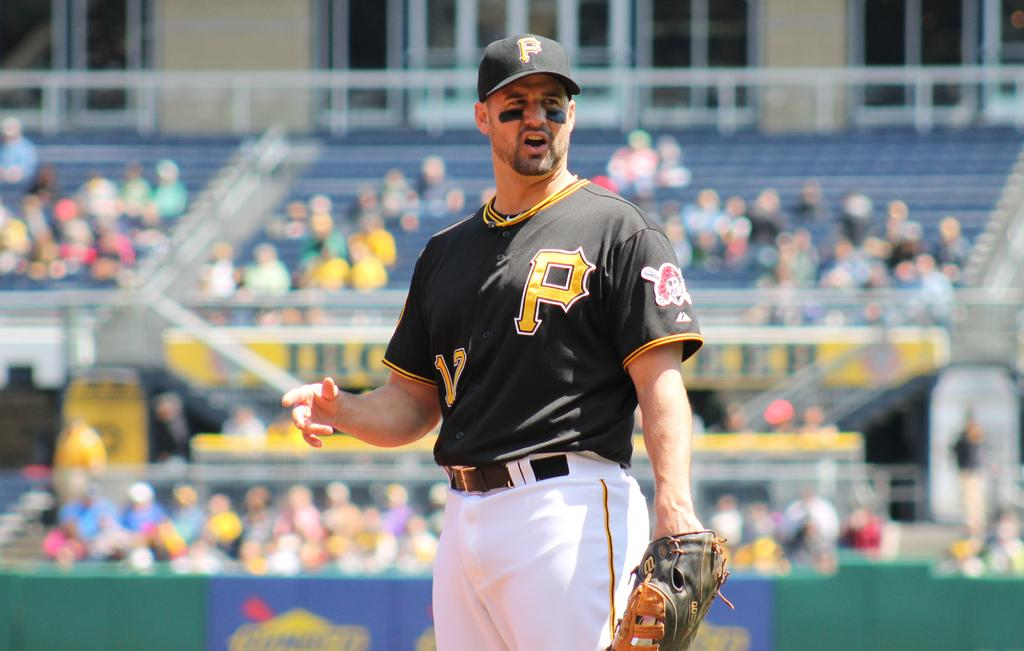<image>
Give a short and clear explanation of the subsequent image. A sportsperson wearing a baseball cap and shirt, both of which have the letter P on. 